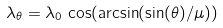<formula> <loc_0><loc_0><loc_500><loc_500>\lambda _ { \theta } = \lambda _ { 0 } \, \cos ( \arcsin ( \sin ( \theta ) / \mu ) )</formula> 